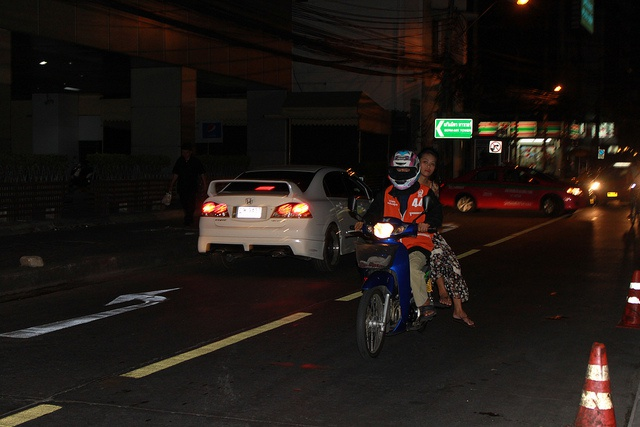Describe the objects in this image and their specific colors. I can see car in black and gray tones, motorcycle in black, maroon, gray, and brown tones, car in black, maroon, and brown tones, people in black, brown, gray, and maroon tones, and people in black, maroon, and gray tones in this image. 